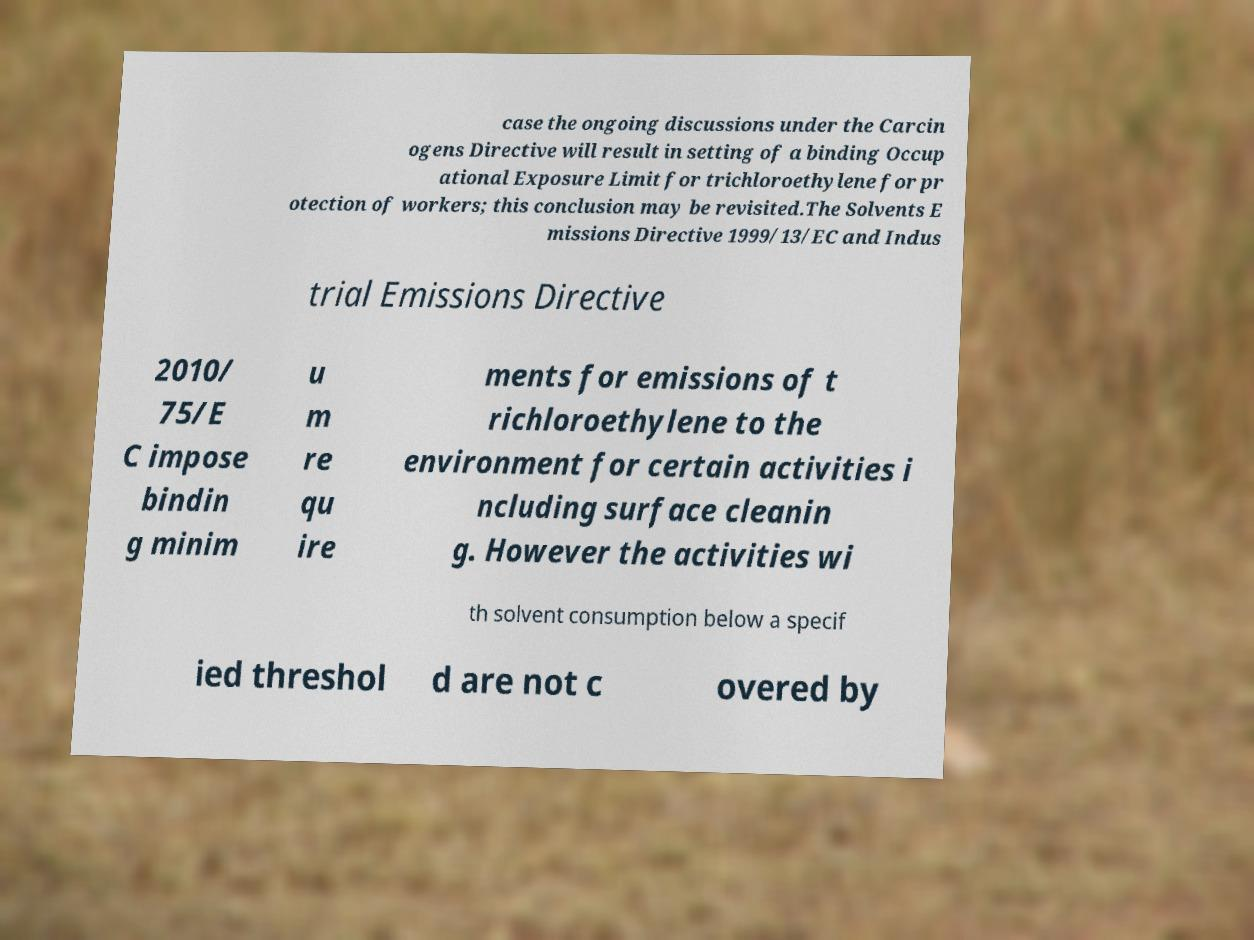There's text embedded in this image that I need extracted. Can you transcribe it verbatim? case the ongoing discussions under the Carcin ogens Directive will result in setting of a binding Occup ational Exposure Limit for trichloroethylene for pr otection of workers; this conclusion may be revisited.The Solvents E missions Directive 1999/13/EC and Indus trial Emissions Directive 2010/ 75/E C impose bindin g minim u m re qu ire ments for emissions of t richloroethylene to the environment for certain activities i ncluding surface cleanin g. However the activities wi th solvent consumption below a specif ied threshol d are not c overed by 